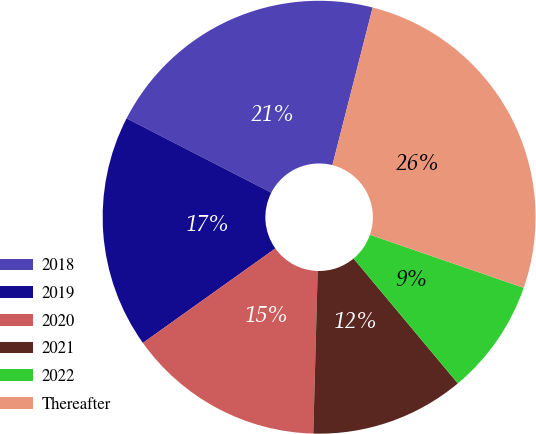Convert chart to OTSL. <chart><loc_0><loc_0><loc_500><loc_500><pie_chart><fcel>2018<fcel>2019<fcel>2020<fcel>2021<fcel>2022<fcel>Thereafter<nl><fcel>21.43%<fcel>17.41%<fcel>14.71%<fcel>11.5%<fcel>8.64%<fcel>26.31%<nl></chart> 